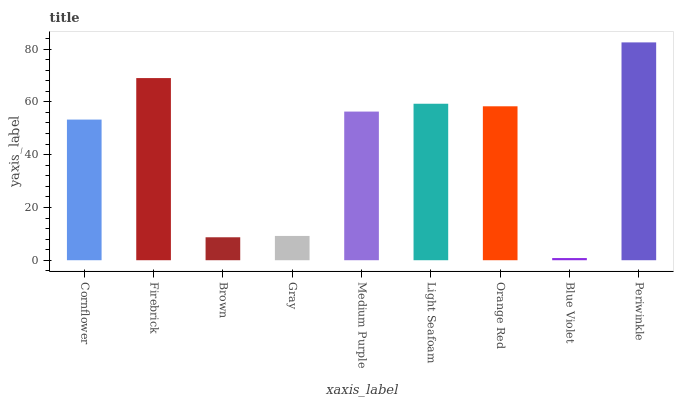Is Firebrick the minimum?
Answer yes or no. No. Is Firebrick the maximum?
Answer yes or no. No. Is Firebrick greater than Cornflower?
Answer yes or no. Yes. Is Cornflower less than Firebrick?
Answer yes or no. Yes. Is Cornflower greater than Firebrick?
Answer yes or no. No. Is Firebrick less than Cornflower?
Answer yes or no. No. Is Medium Purple the high median?
Answer yes or no. Yes. Is Medium Purple the low median?
Answer yes or no. Yes. Is Gray the high median?
Answer yes or no. No. Is Cornflower the low median?
Answer yes or no. No. 